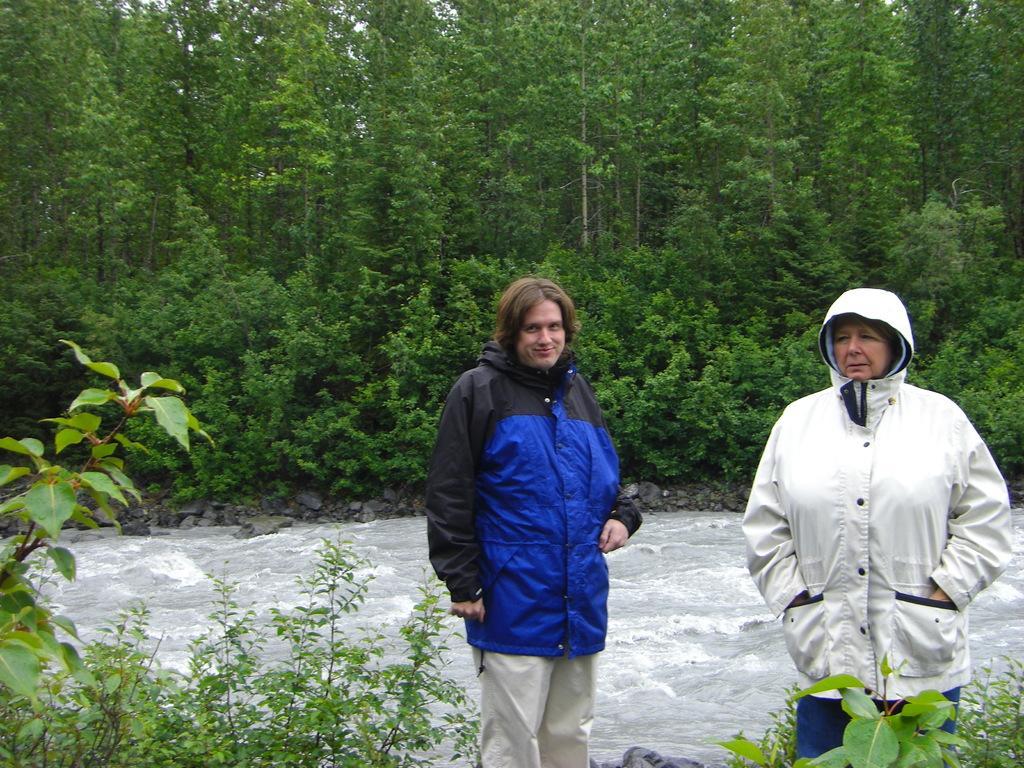How would you summarize this image in a sentence or two? In this image we can see two people standing and there is a water flow and we can see some plants and trees in the background. 